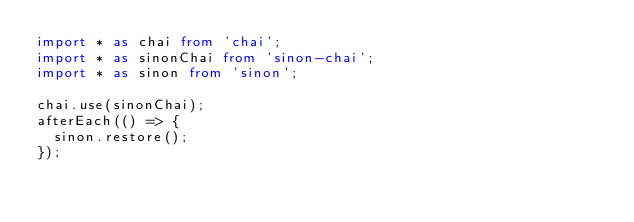Convert code to text. <code><loc_0><loc_0><loc_500><loc_500><_TypeScript_>import * as chai from 'chai';
import * as sinonChai from 'sinon-chai';
import * as sinon from 'sinon';

chai.use(sinonChai);
afterEach(() => {
  sinon.restore();
});
</code> 